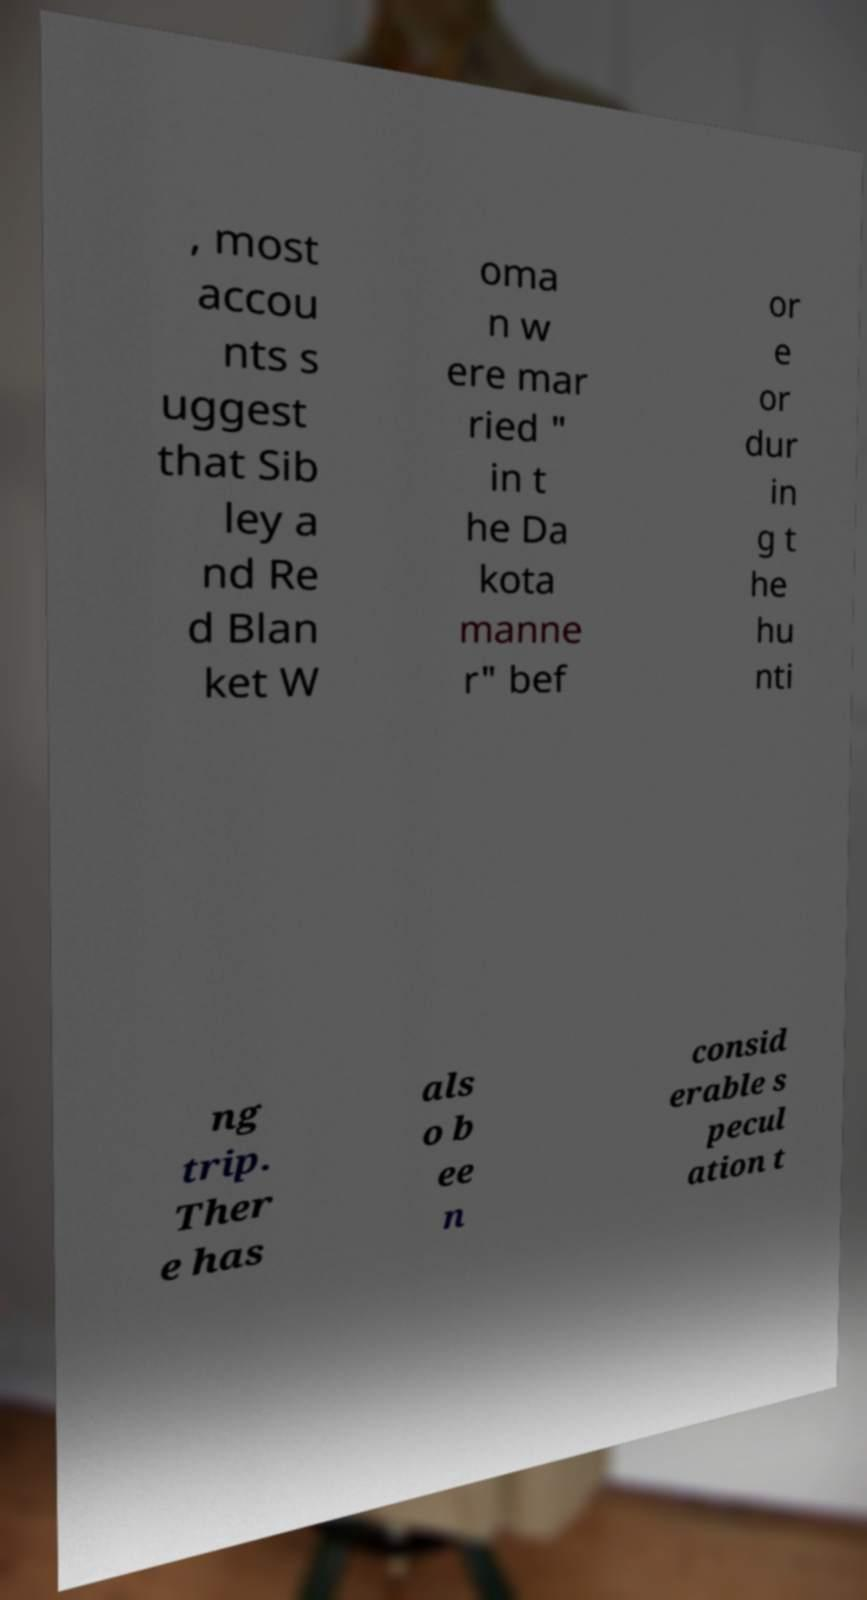Can you accurately transcribe the text from the provided image for me? , most accou nts s uggest that Sib ley a nd Re d Blan ket W oma n w ere mar ried " in t he Da kota manne r" bef or e or dur in g t he hu nti ng trip. Ther e has als o b ee n consid erable s pecul ation t 